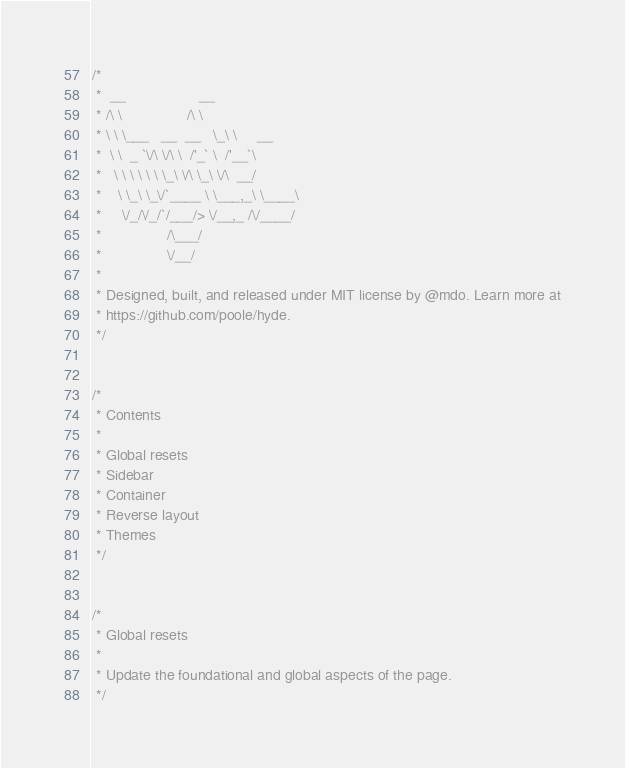Convert code to text. <code><loc_0><loc_0><loc_500><loc_500><_CSS_>/*
 *  __                  __
 * /\ \                /\ \
 * \ \ \___   __  __   \_\ \     __
 *  \ \  _ `\/\ \/\ \  /'_` \  /'__`\
 *   \ \ \ \ \ \ \_\ \/\ \_\ \/\  __/
 *    \ \_\ \_\/`____ \ \___,_\ \____\
 *     \/_/\/_/`/___/> \/__,_ /\/____/
 *                /\___/
 *                \/__/
 *
 * Designed, built, and released under MIT license by @mdo. Learn more at
 * https://github.com/poole/hyde.
 */


/*
 * Contents
 *
 * Global resets
 * Sidebar
 * Container
 * Reverse layout
 * Themes
 */


/*
 * Global resets
 *
 * Update the foundational and global aspects of the page.
 */
</code> 